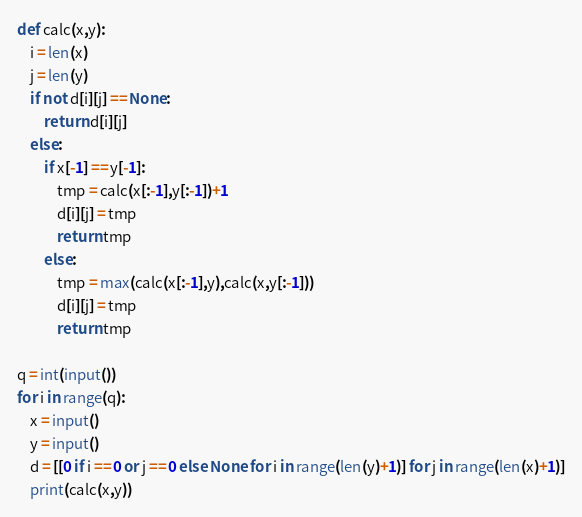Convert code to text. <code><loc_0><loc_0><loc_500><loc_500><_Python_>def calc(x,y):
    i = len(x)
    j = len(y)
    if not d[i][j] == None:
        return d[i][j]
    else:
        if x[-1] == y[-1]:
            tmp = calc(x[:-1],y[:-1])+1
            d[i][j] = tmp
            return tmp
        else:
            tmp = max(calc(x[:-1],y),calc(x,y[:-1]))
            d[i][j] = tmp
            return tmp
        
q = int(input())
for i in range(q):
    x = input()
    y = input()
    d = [[0 if i == 0 or j == 0 else None for i in range(len(y)+1)] for j in range(len(x)+1)]
    print(calc(x,y))
</code> 